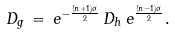Convert formula to latex. <formula><loc_0><loc_0><loc_500><loc_500>D _ { g } \, = \, e ^ { - \frac { ( n + 1 ) \sigma } { 2 } } \, D _ { h } \, e ^ { \frac { ( n - 1 ) \sigma } { 2 } } .</formula> 